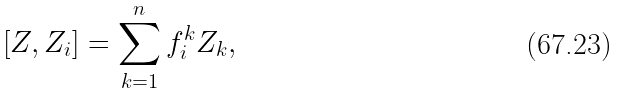Convert formula to latex. <formula><loc_0><loc_0><loc_500><loc_500>[ Z , Z _ { i } ] = \sum _ { k = 1 } ^ { n } f _ { i } ^ { k } Z _ { k } ,</formula> 